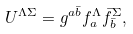<formula> <loc_0><loc_0><loc_500><loc_500>U ^ { \Lambda \Sigma } = g ^ { a \bar { b } } f _ { a } ^ { \Lambda } \bar { f } _ { \bar { b } } ^ { \Sigma } ,</formula> 